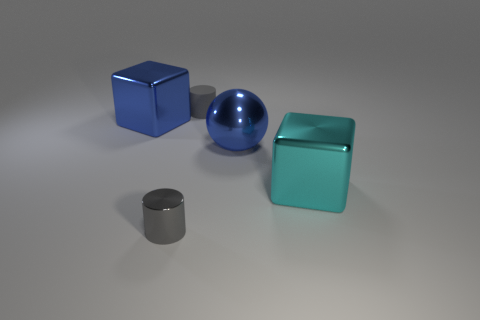There is a object that is the same color as the tiny metal cylinder; what size is it?
Give a very brief answer. Small. What number of other things are there of the same color as the shiny cylinder?
Your answer should be very brief. 1. There is a big thing that is the same color as the large sphere; what is its material?
Give a very brief answer. Metal. What number of small things are either cyan blocks or shiny spheres?
Offer a terse response. 0. The large sphere is what color?
Offer a very short reply. Blue. There is a gray thing that is in front of the big metal ball; are there any large cubes to the left of it?
Keep it short and to the point. Yes. Are there fewer cyan blocks that are behind the gray matte object than small matte things?
Ensure brevity in your answer.  Yes. Is the material of the large blue thing right of the tiny gray matte cylinder the same as the big cyan thing?
Provide a short and direct response. Yes. What color is the small cylinder that is made of the same material as the large cyan block?
Keep it short and to the point. Gray. Are there fewer gray cylinders that are left of the matte thing than gray shiny cylinders behind the large cyan object?
Give a very brief answer. No. 